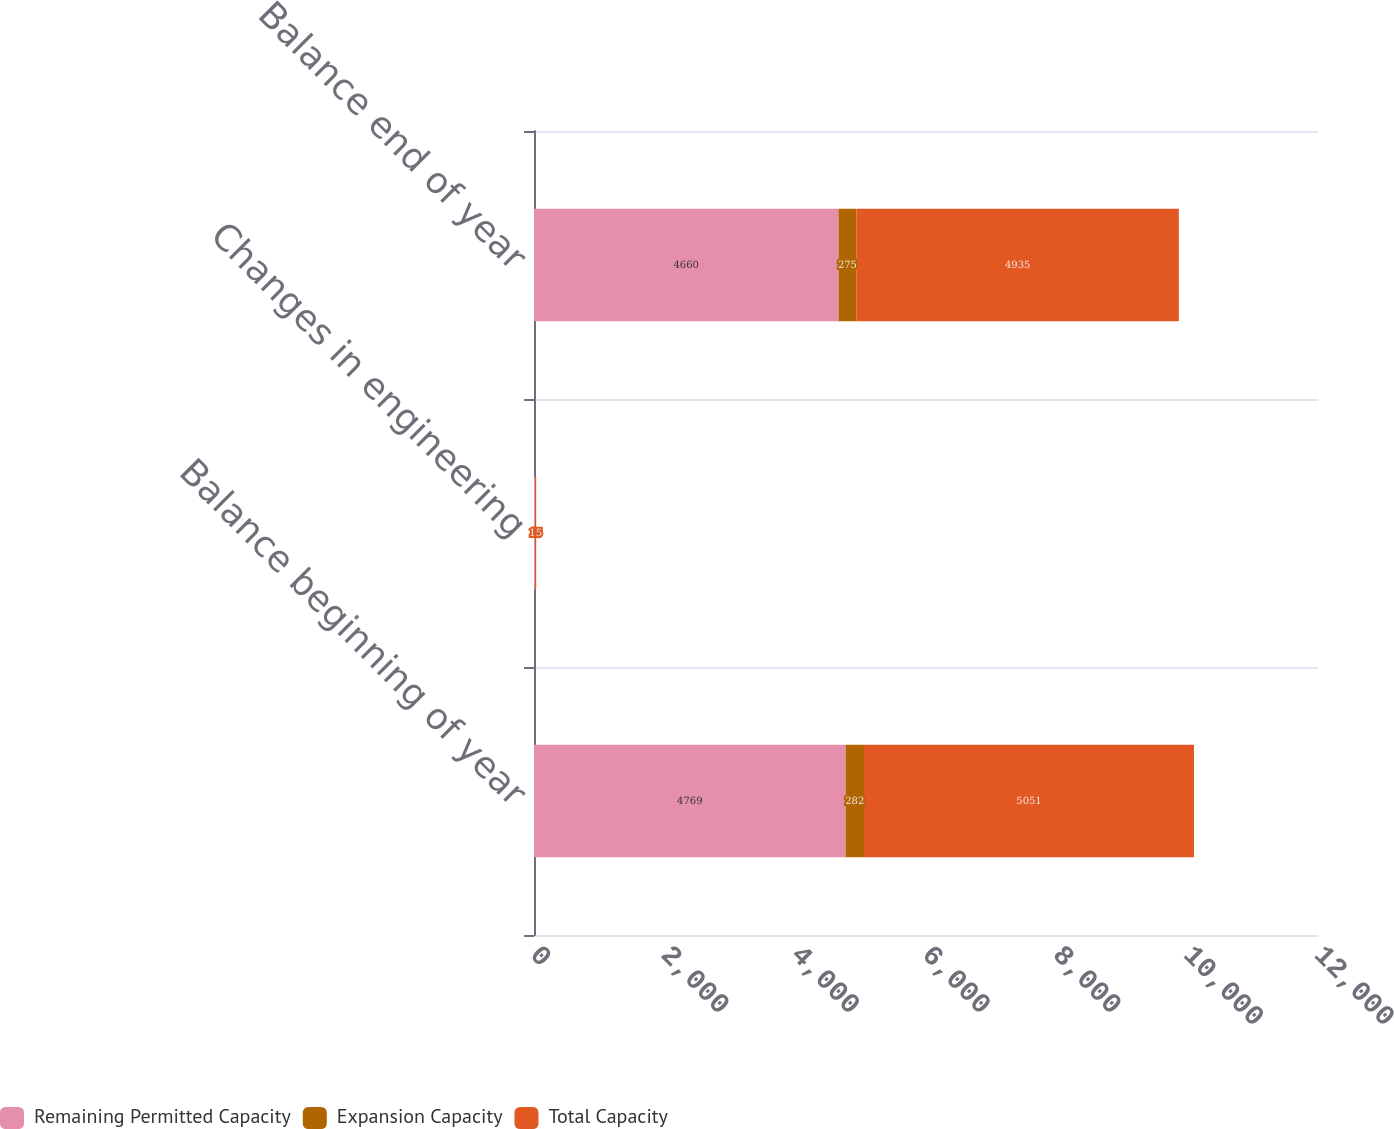Convert chart. <chart><loc_0><loc_0><loc_500><loc_500><stacked_bar_chart><ecel><fcel>Balance beginning of year<fcel>Changes in engineering<fcel>Balance end of year<nl><fcel>Remaining Permitted Capacity<fcel>4769<fcel>17<fcel>4660<nl><fcel>Expansion Capacity<fcel>282<fcel>2<fcel>275<nl><fcel>Total Capacity<fcel>5051<fcel>15<fcel>4935<nl></chart> 